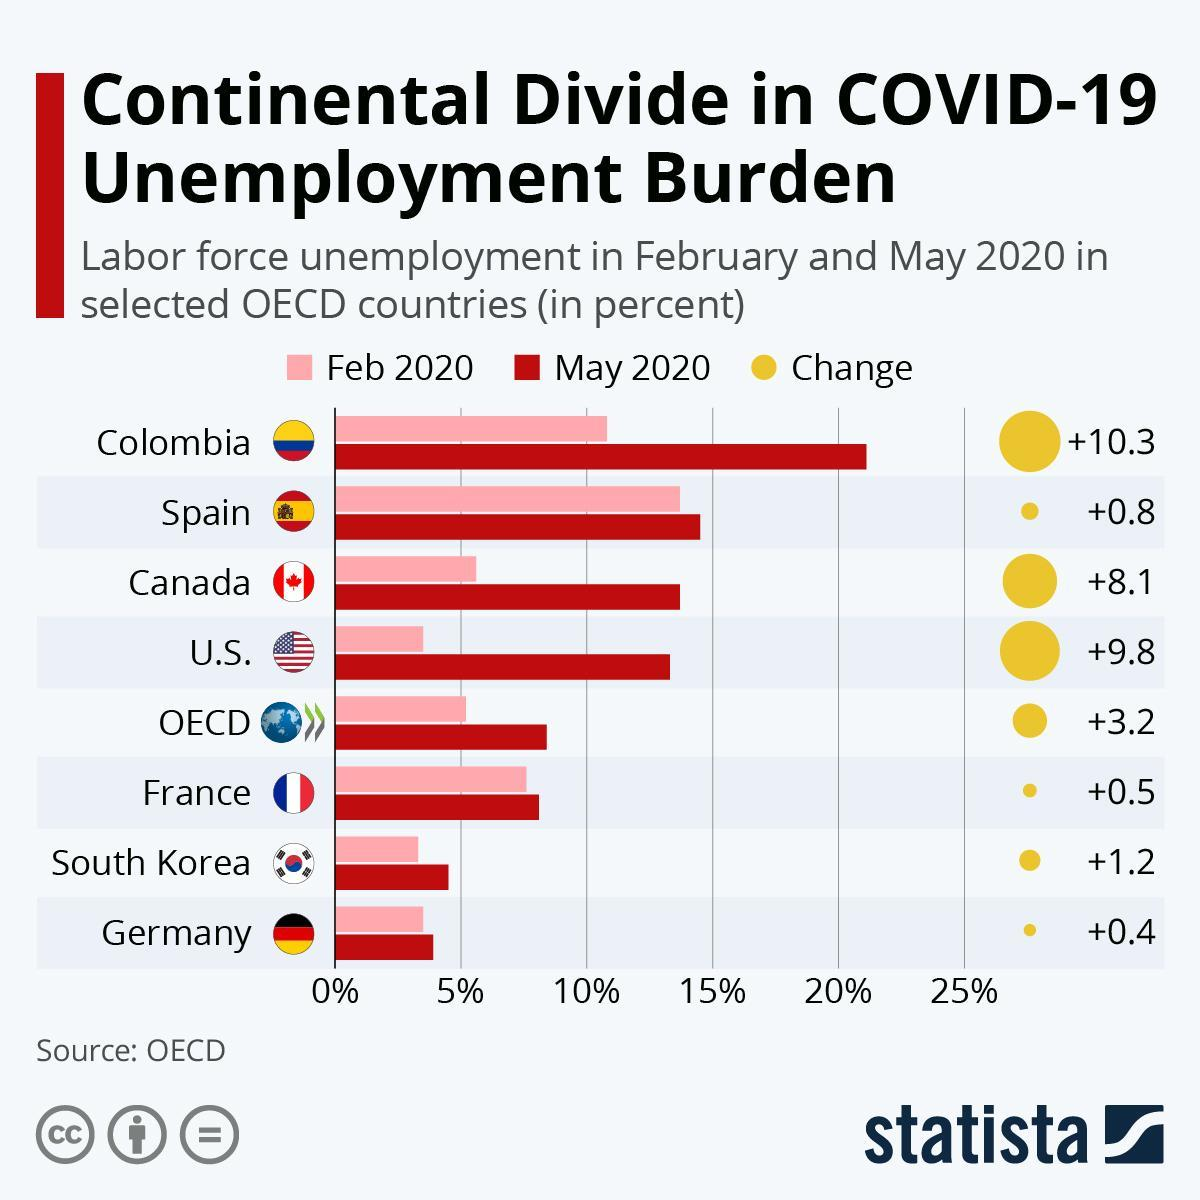How many OECD countries are listed?
Answer the question with a short phrase. 7 Which country had labor force unemployment go beyond 20% in May 2020? Colombia Which countries had labor force unemployment below 5%? South Korea, Germany 